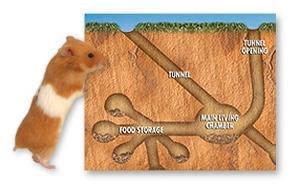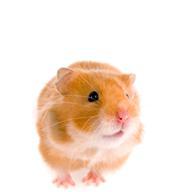The first image is the image on the left, the second image is the image on the right. Evaluate the accuracy of this statement regarding the images: "There are exactly two hamsters in total.". Is it true? Answer yes or no. Yes. 